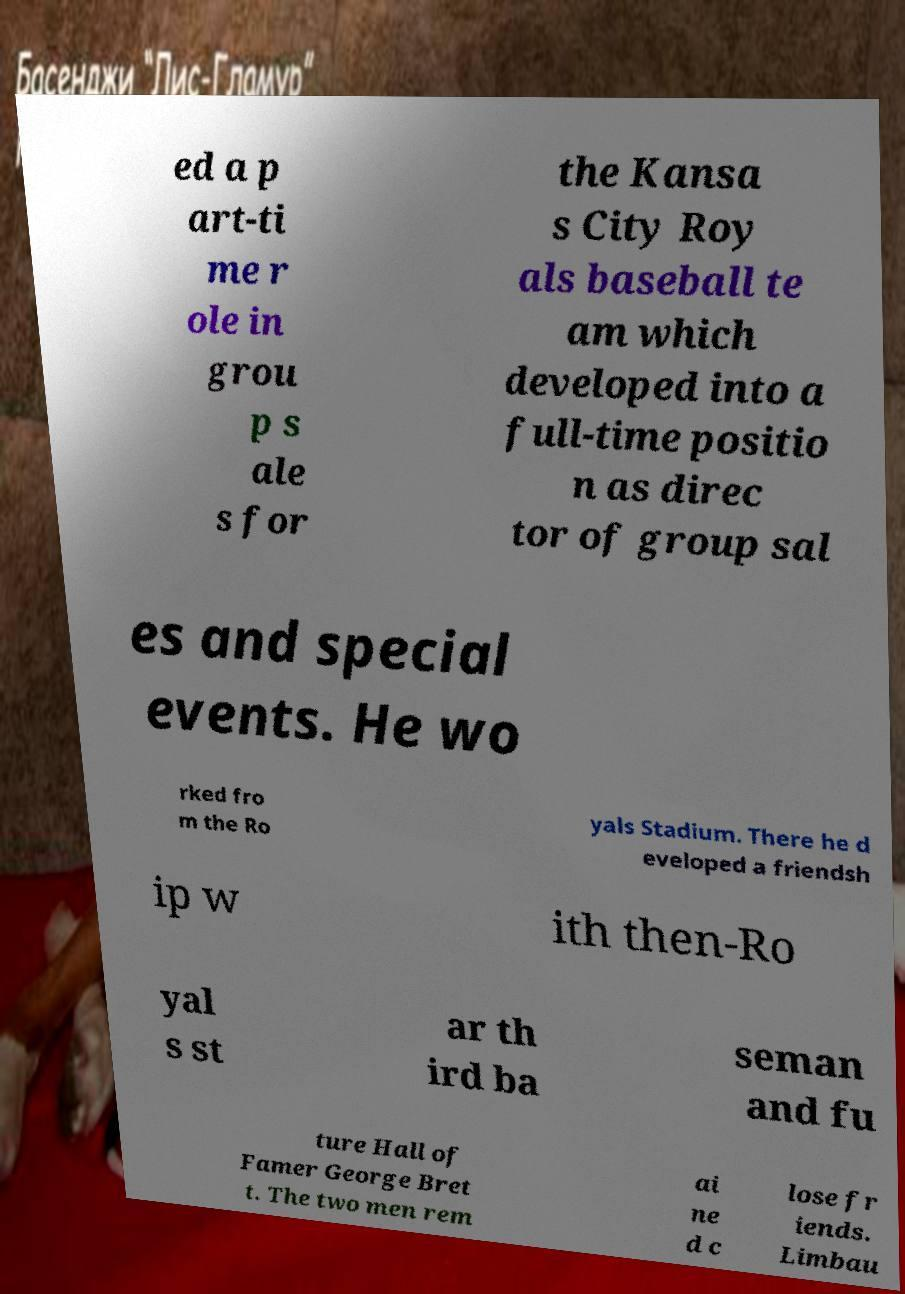Could you extract and type out the text from this image? ed a p art-ti me r ole in grou p s ale s for the Kansa s City Roy als baseball te am which developed into a full-time positio n as direc tor of group sal es and special events. He wo rked fro m the Ro yals Stadium. There he d eveloped a friendsh ip w ith then-Ro yal s st ar th ird ba seman and fu ture Hall of Famer George Bret t. The two men rem ai ne d c lose fr iends. Limbau 